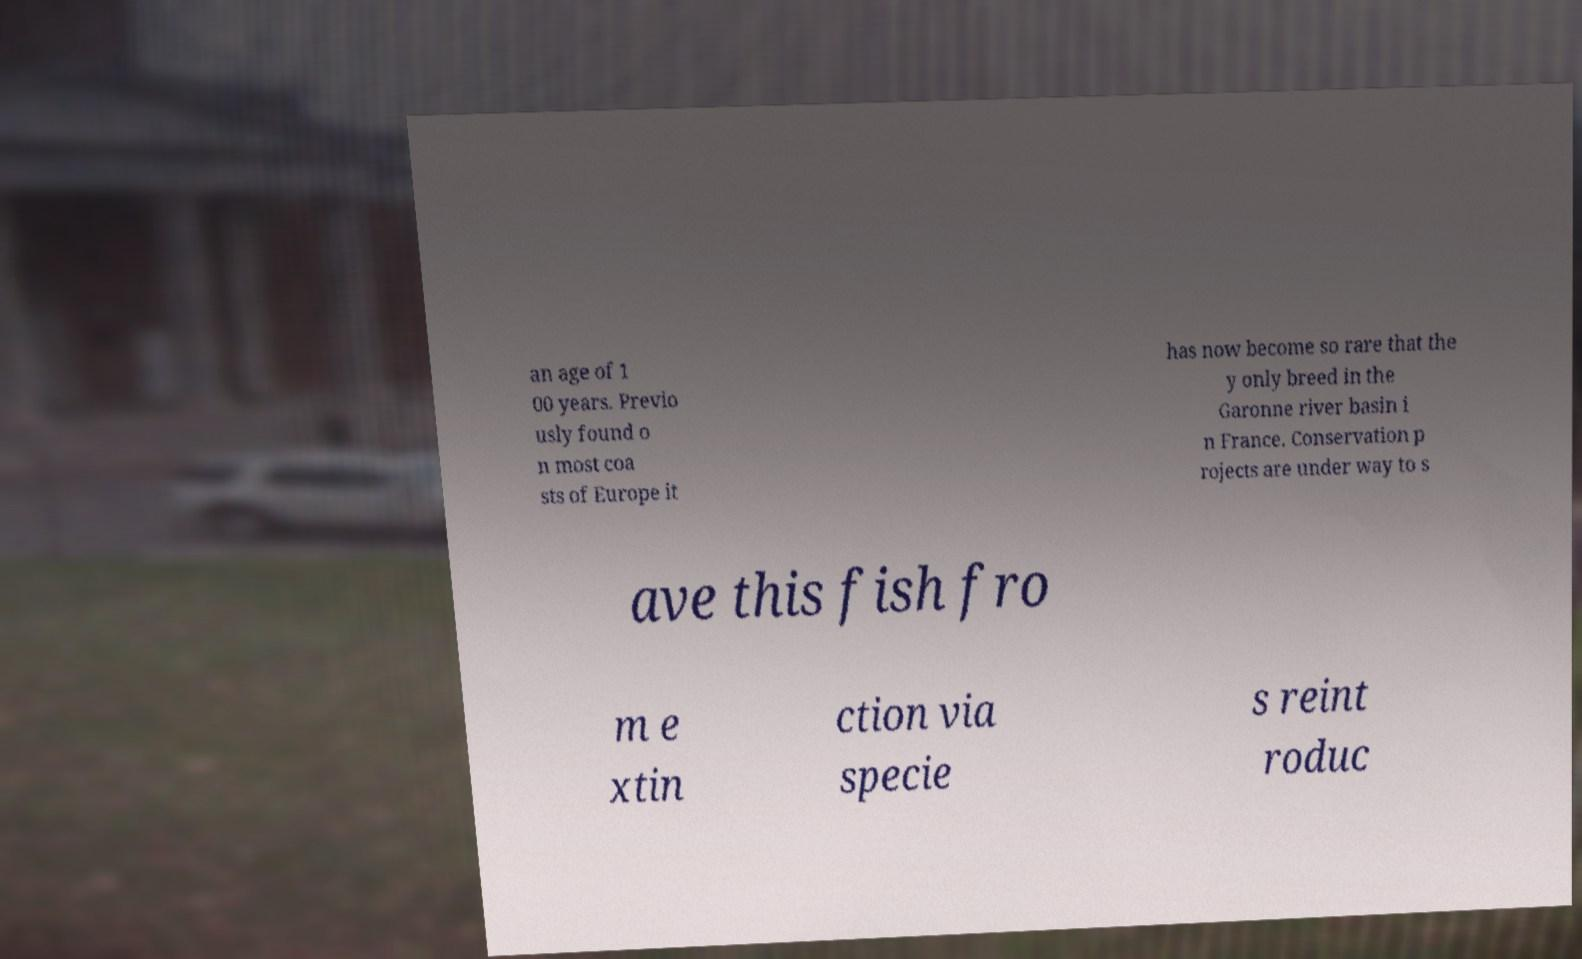Could you extract and type out the text from this image? an age of 1 00 years. Previo usly found o n most coa sts of Europe it has now become so rare that the y only breed in the Garonne river basin i n France. Conservation p rojects are under way to s ave this fish fro m e xtin ction via specie s reint roduc 